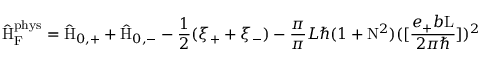Convert formula to latex. <formula><loc_0><loc_0><loc_500><loc_500>\hat { H } _ { F } ^ { p h y s } = \hat { H } _ { 0 , + } + \hat { H } _ { 0 , - } - \frac { 1 } { 2 } ( \xi _ { + } + \xi _ { - } ) - \frac { \pi } { \pi } { L } { } ( 1 + N ^ { 2 } ) ( [ \frac { e _ { + } b L } { 2 { \pi } { } } ] ) ^ { 2 }</formula> 